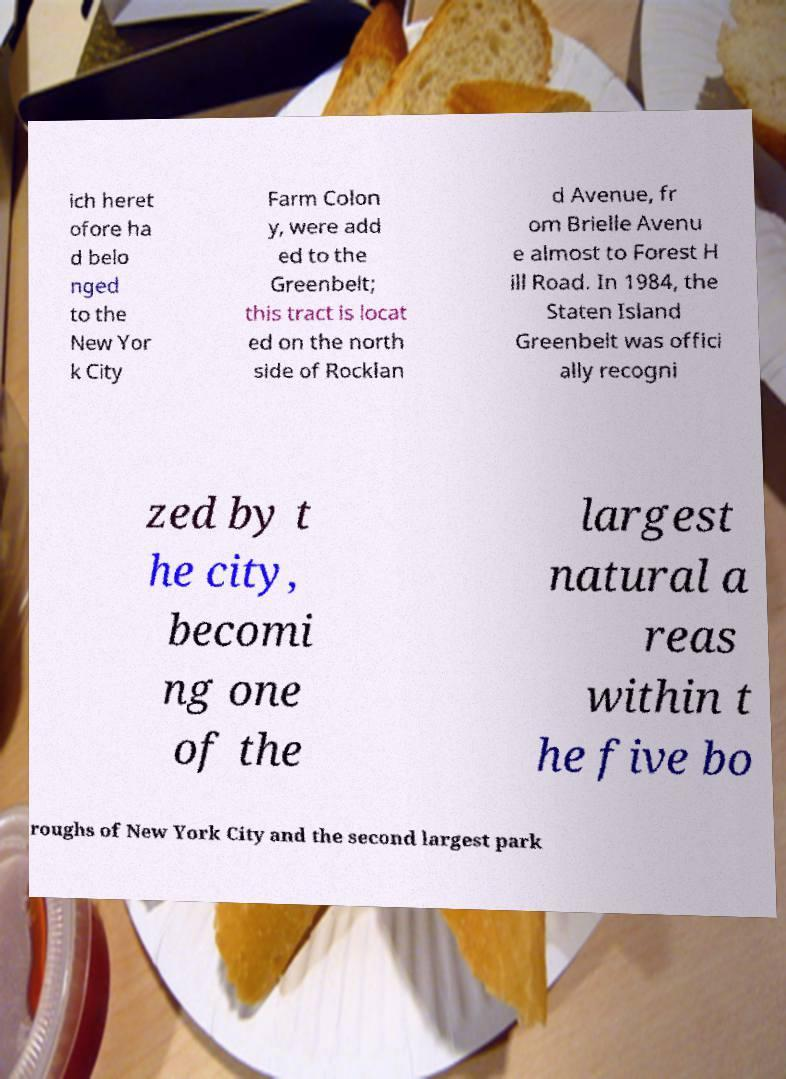There's text embedded in this image that I need extracted. Can you transcribe it verbatim? ich heret ofore ha d belo nged to the New Yor k City Farm Colon y, were add ed to the Greenbelt; this tract is locat ed on the north side of Rocklan d Avenue, fr om Brielle Avenu e almost to Forest H ill Road. In 1984, the Staten Island Greenbelt was offici ally recogni zed by t he city, becomi ng one of the largest natural a reas within t he five bo roughs of New York City and the second largest park 